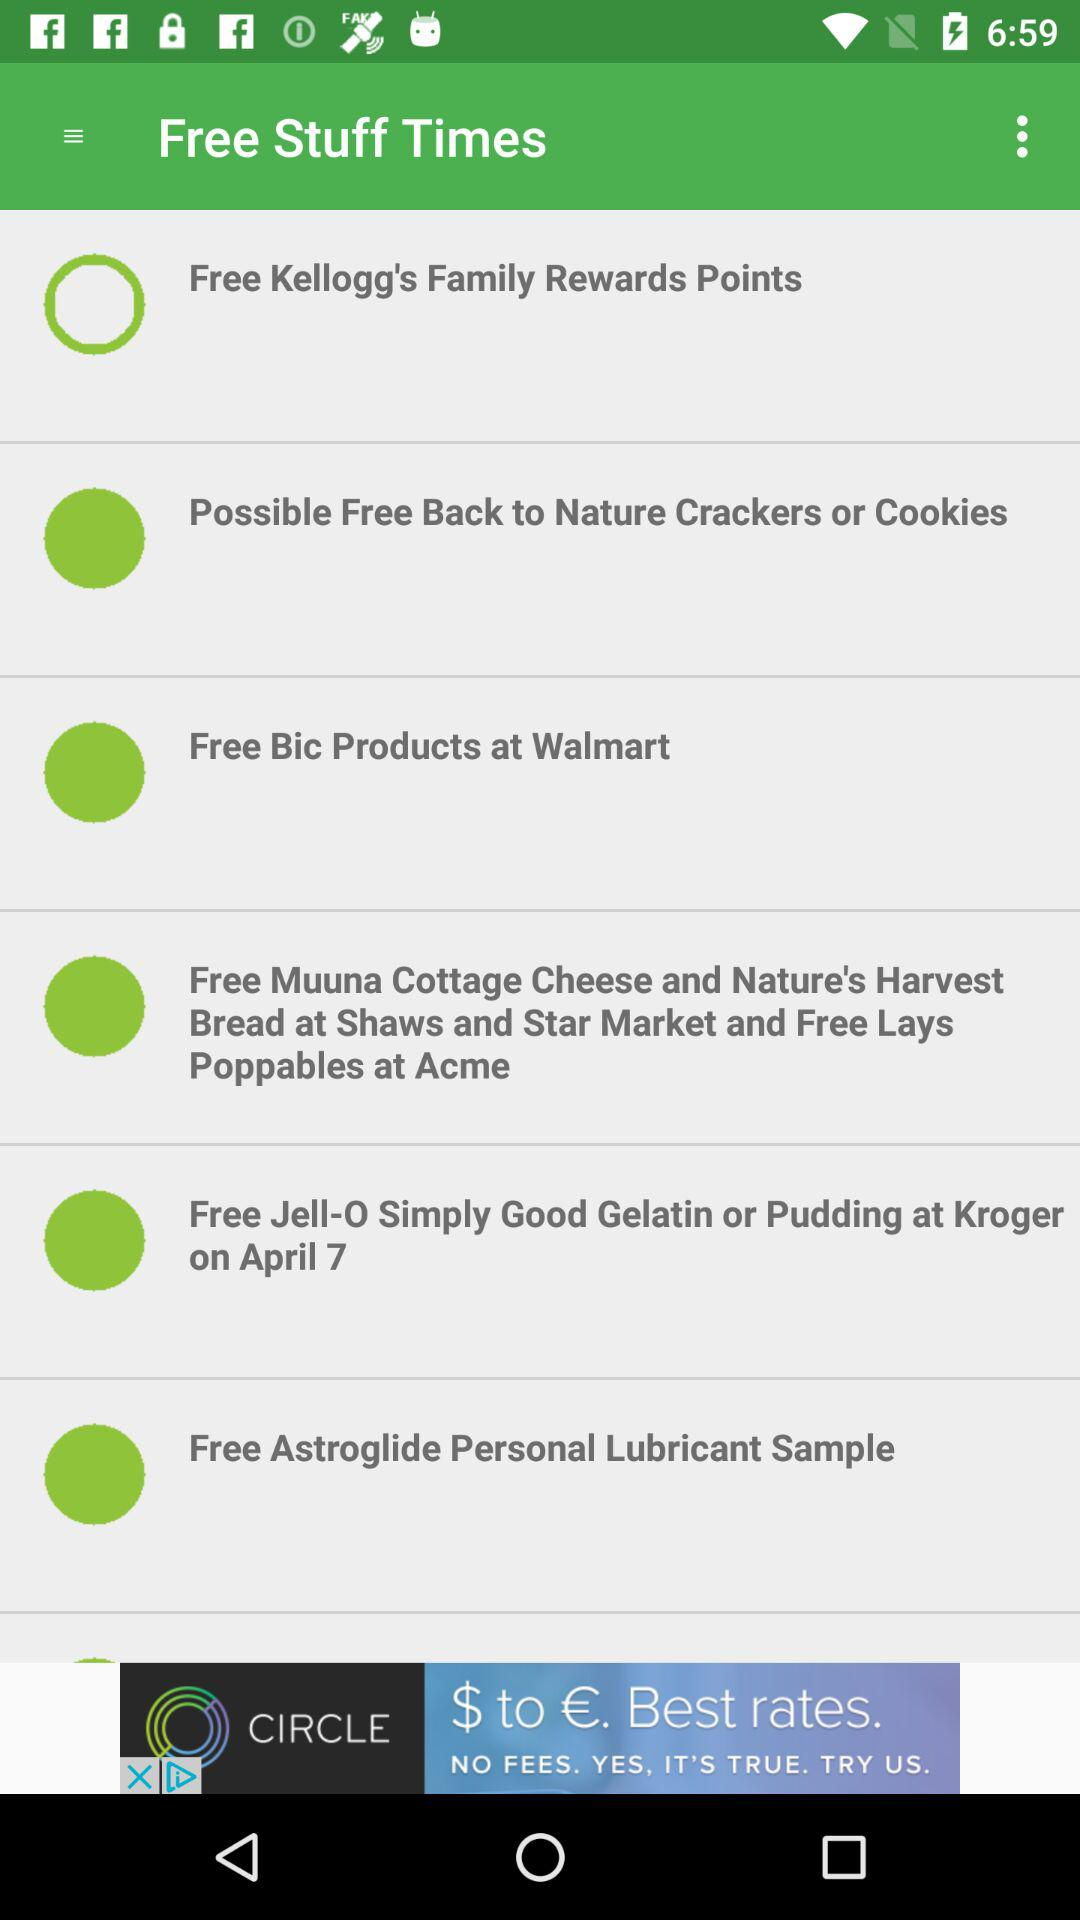Which option is not selected? The unselected option is "Free Kellogg's Family Rewards Points". 